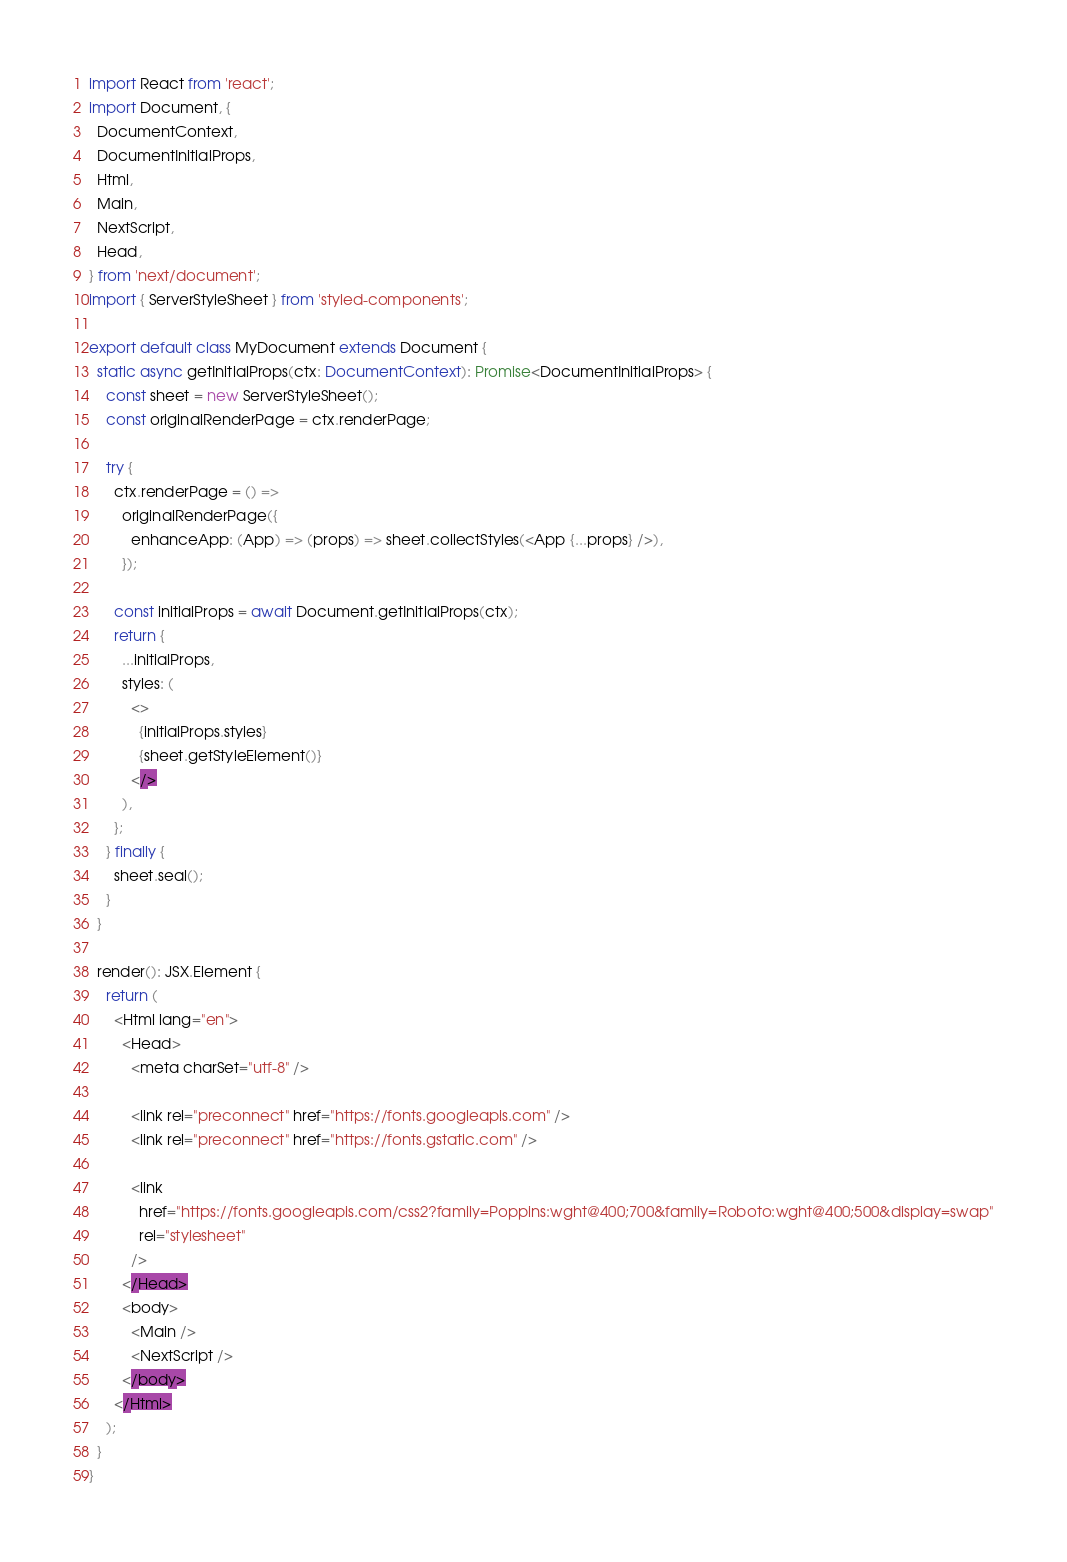Convert code to text. <code><loc_0><loc_0><loc_500><loc_500><_TypeScript_>import React from 'react';
import Document, {
  DocumentContext,
  DocumentInitialProps,
  Html,
  Main,
  NextScript,
  Head,
} from 'next/document';
import { ServerStyleSheet } from 'styled-components';

export default class MyDocument extends Document {
  static async getInitialProps(ctx: DocumentContext): Promise<DocumentInitialProps> {
    const sheet = new ServerStyleSheet();
    const originalRenderPage = ctx.renderPage;

    try {
      ctx.renderPage = () =>
        originalRenderPage({
          enhanceApp: (App) => (props) => sheet.collectStyles(<App {...props} />),
        });

      const initialProps = await Document.getInitialProps(ctx);
      return {
        ...initialProps,
        styles: (
          <>
            {initialProps.styles}
            {sheet.getStyleElement()}
          </>
        ),
      };
    } finally {
      sheet.seal();
    }
  }

  render(): JSX.Element {
    return (
      <Html lang="en">
        <Head>
          <meta charSet="utf-8" />

          <link rel="preconnect" href="https://fonts.googleapis.com" />
          <link rel="preconnect" href="https://fonts.gstatic.com" />

          <link
            href="https://fonts.googleapis.com/css2?family=Poppins:wght@400;700&family=Roboto:wght@400;500&display=swap"
            rel="stylesheet"
          />
        </Head>
        <body>
          <Main />
          <NextScript />
        </body>
      </Html>
    );
  }
}
</code> 